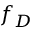<formula> <loc_0><loc_0><loc_500><loc_500>f _ { D }</formula> 